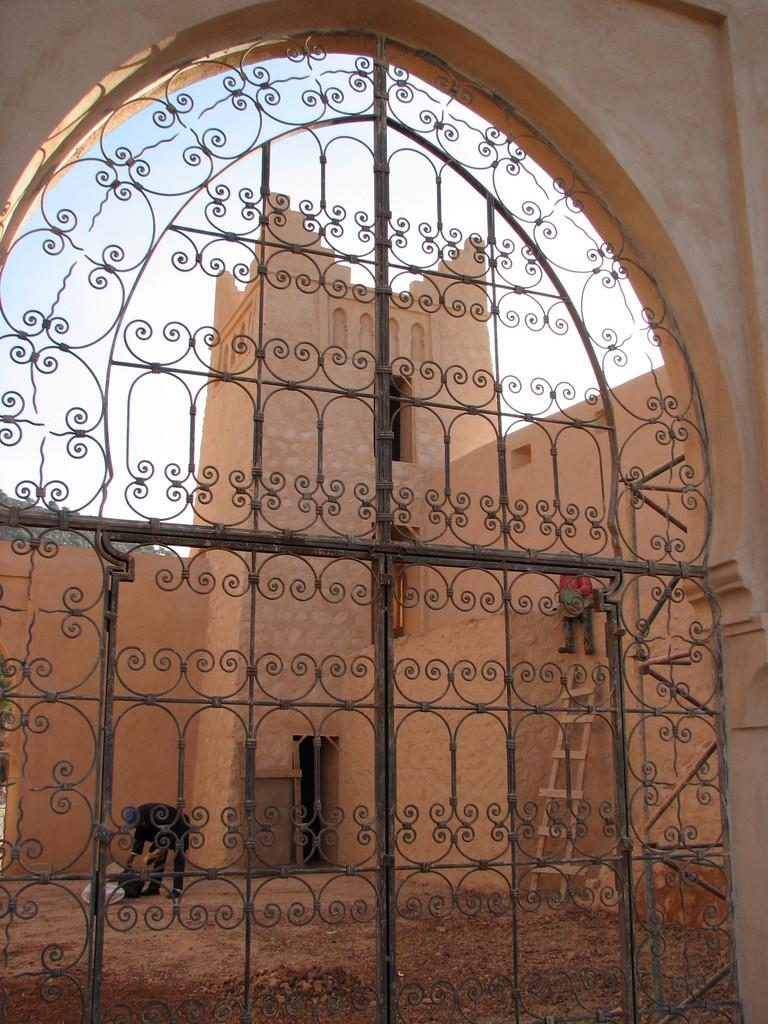What structure can be seen in the image? There is a gate in the image. Who or what can be seen through the gate? A person is visible through the gate. What else is present in the image besides the gate and the person? There is a building in the image. How many dolls are sitting on the frame in the image? There are no dolls or frames present in the image. What type of men can be seen walking in the background of the image? There are no men or background visible in the image; it only features a gate, a person, and a building. 